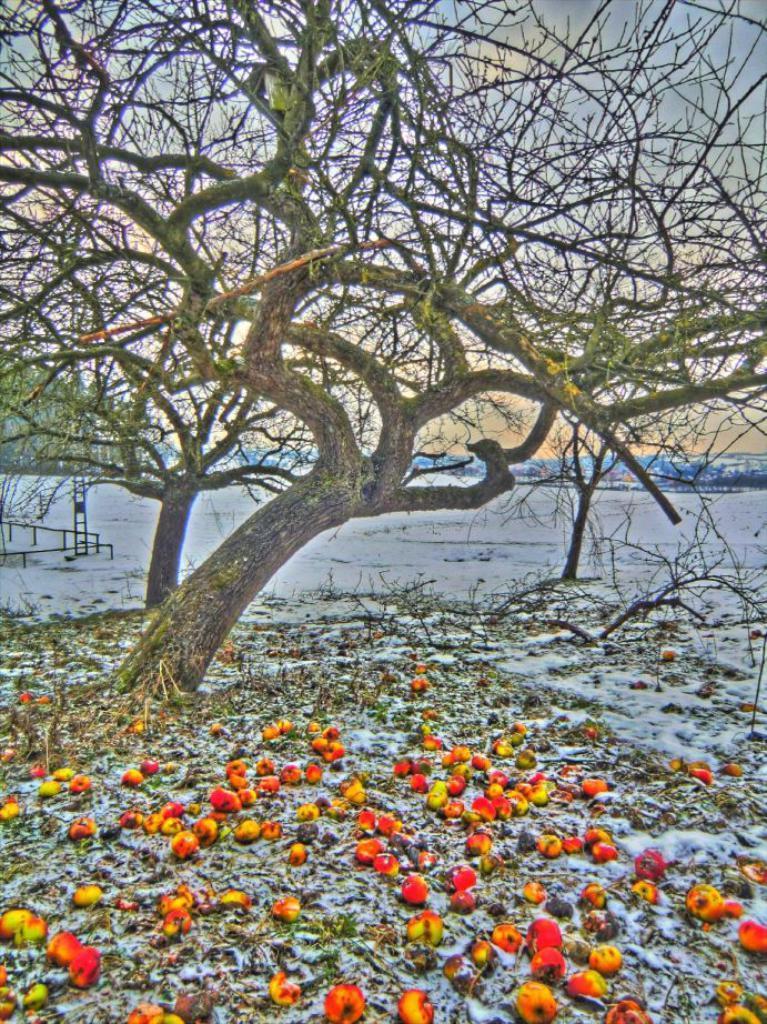How would you summarize this image in a sentence or two? In the center of the image, we can see a tree and there are rods and there is a pole. At the bottom, there are apples and there is snow. 